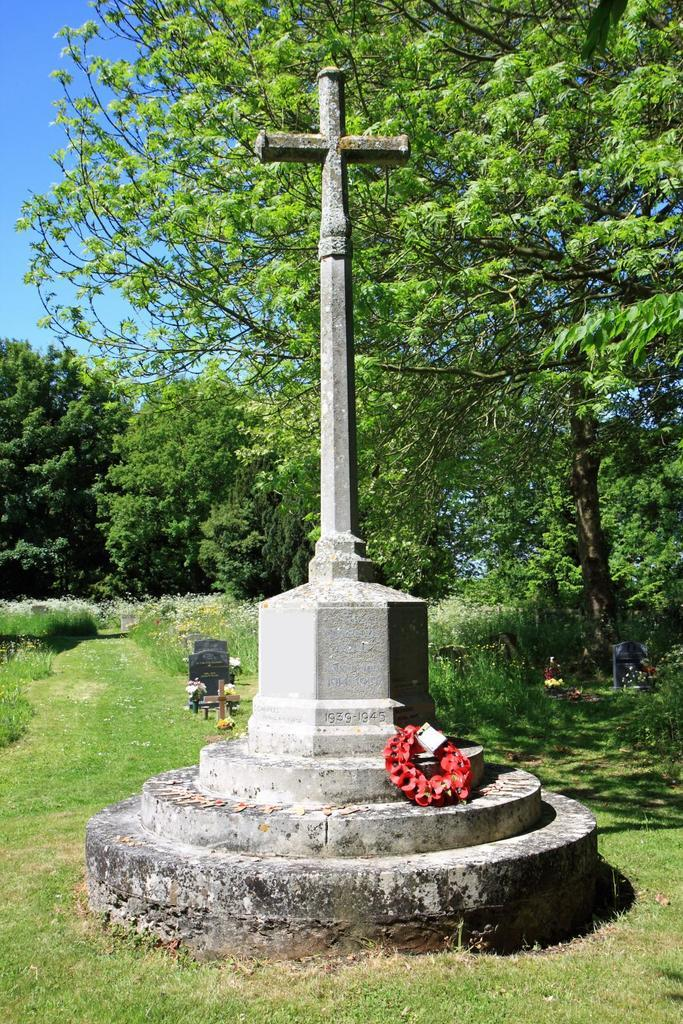What is the main subject in the image? There is a structure in the image. What feature of the structure can be seen in the image? There are stairs in the image. What decorative element is present in the image? There is a garland in the image. What type of vegetation is visible at the bottom of the image? Grass is visible at the bottom of the image. What can be seen in the background of the image? There are trees and the sky visible in the background of the image. What type of wristwatch is visible on the person's wrist in the image? There is no person or wristwatch present in the image. How many rooms can be seen in the image? The image does not show any rooms; it features a structure with stairs and a garland. 